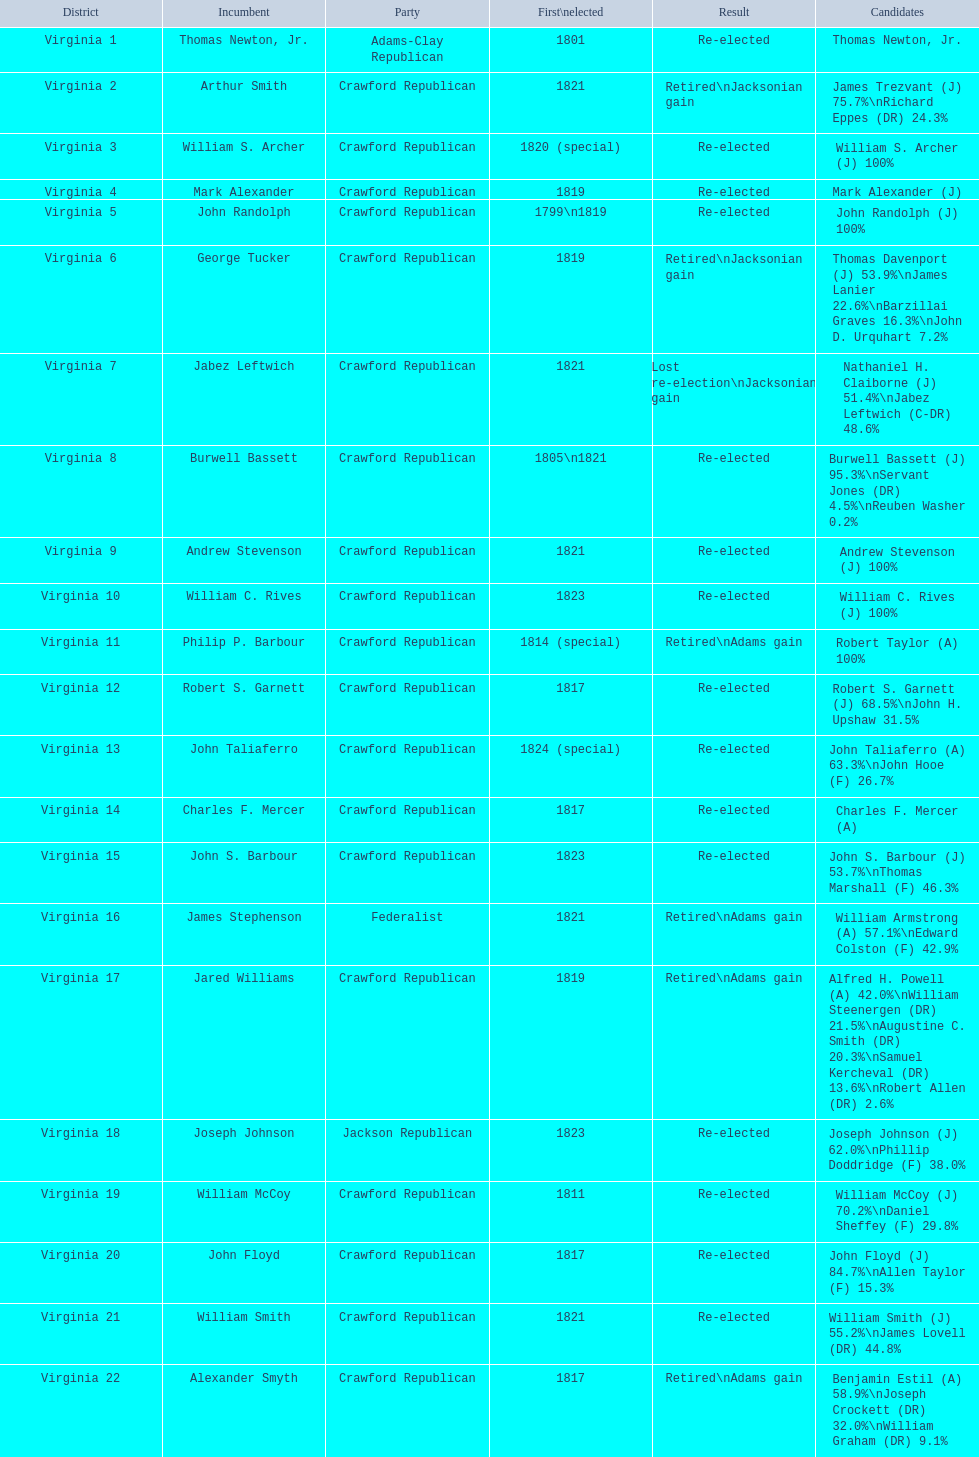What group does a crawford republican belong to? Crawford Republican, Crawford Republican, Crawford Republican, Crawford Republican, Crawford Republican, Crawford Republican, Crawford Republican, Crawford Republican, Crawford Republican, Crawford Republican, Crawford Republican, Crawford Republican, Crawford Republican, Crawford Republican, Crawford Republican, Crawford Republican, Crawford Republican, Crawford Republican, Crawford Republican. What contenders have above 76%? James Trezvant (J) 75.7%\nRichard Eppes (DR) 24.3%, William S. Archer (J) 100%, John Randolph (J) 100%, Burwell Bassett (J) 95.3%\nServant Jones (DR) 4.5%\nReuben Washer 0.2%, Andrew Stevenson (J) 100%, William C. Rives (J) 100%, Robert Taylor (A) 100%, John Floyd (J) 84.7%\nAllen Taylor (F) 15.3%. Which outcome was the retired jacksonian increase? Retired\nJacksonian gain. Who held the previous position? Arthur Smith. 